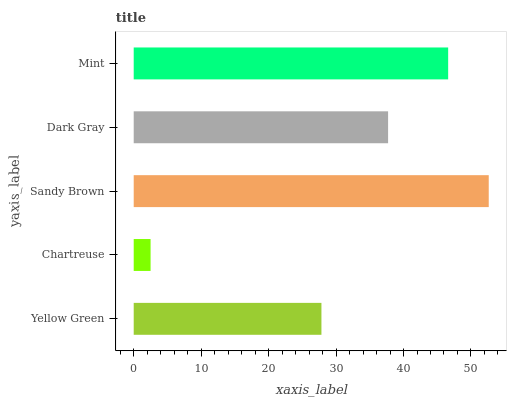Is Chartreuse the minimum?
Answer yes or no. Yes. Is Sandy Brown the maximum?
Answer yes or no. Yes. Is Sandy Brown the minimum?
Answer yes or no. No. Is Chartreuse the maximum?
Answer yes or no. No. Is Sandy Brown greater than Chartreuse?
Answer yes or no. Yes. Is Chartreuse less than Sandy Brown?
Answer yes or no. Yes. Is Chartreuse greater than Sandy Brown?
Answer yes or no. No. Is Sandy Brown less than Chartreuse?
Answer yes or no. No. Is Dark Gray the high median?
Answer yes or no. Yes. Is Dark Gray the low median?
Answer yes or no. Yes. Is Mint the high median?
Answer yes or no. No. Is Sandy Brown the low median?
Answer yes or no. No. 